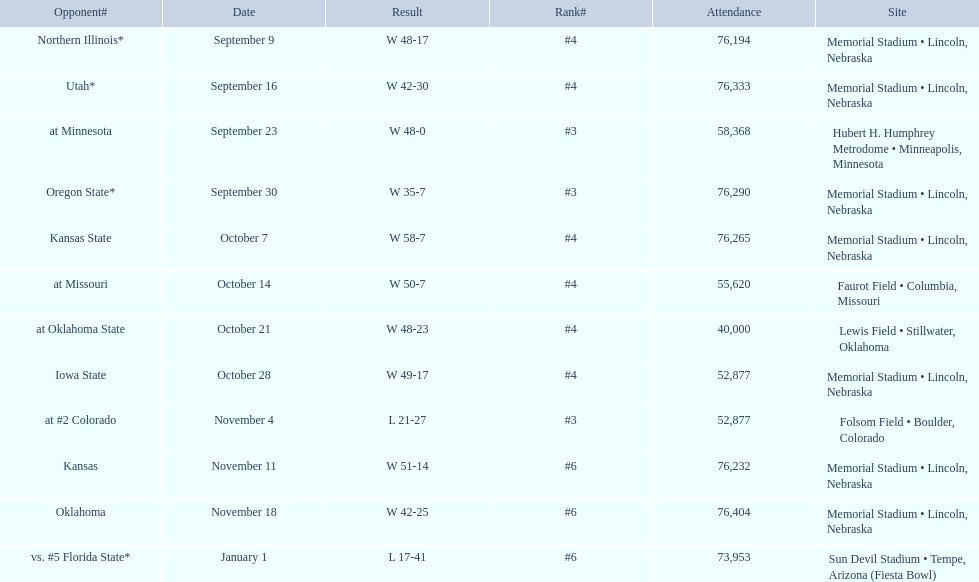What was the attendance count for the oregon state game? 76,290. 